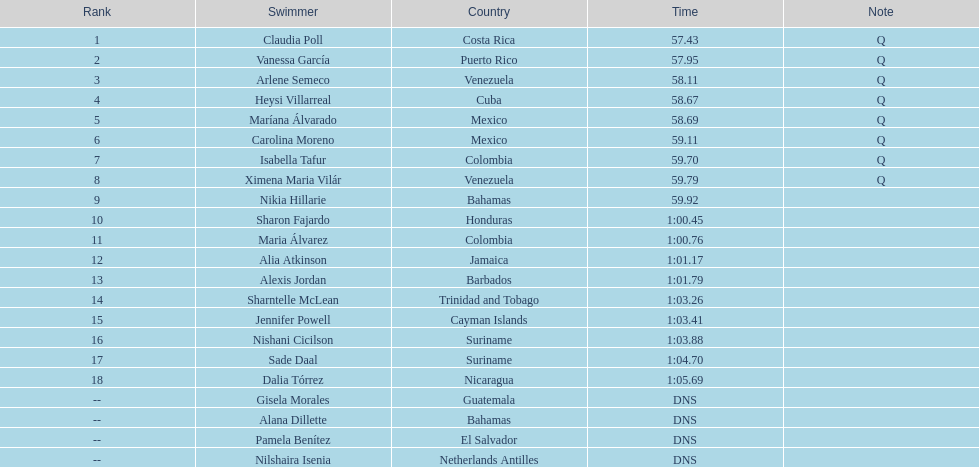What swimmer had the top or first rank? Claudia Poll. 